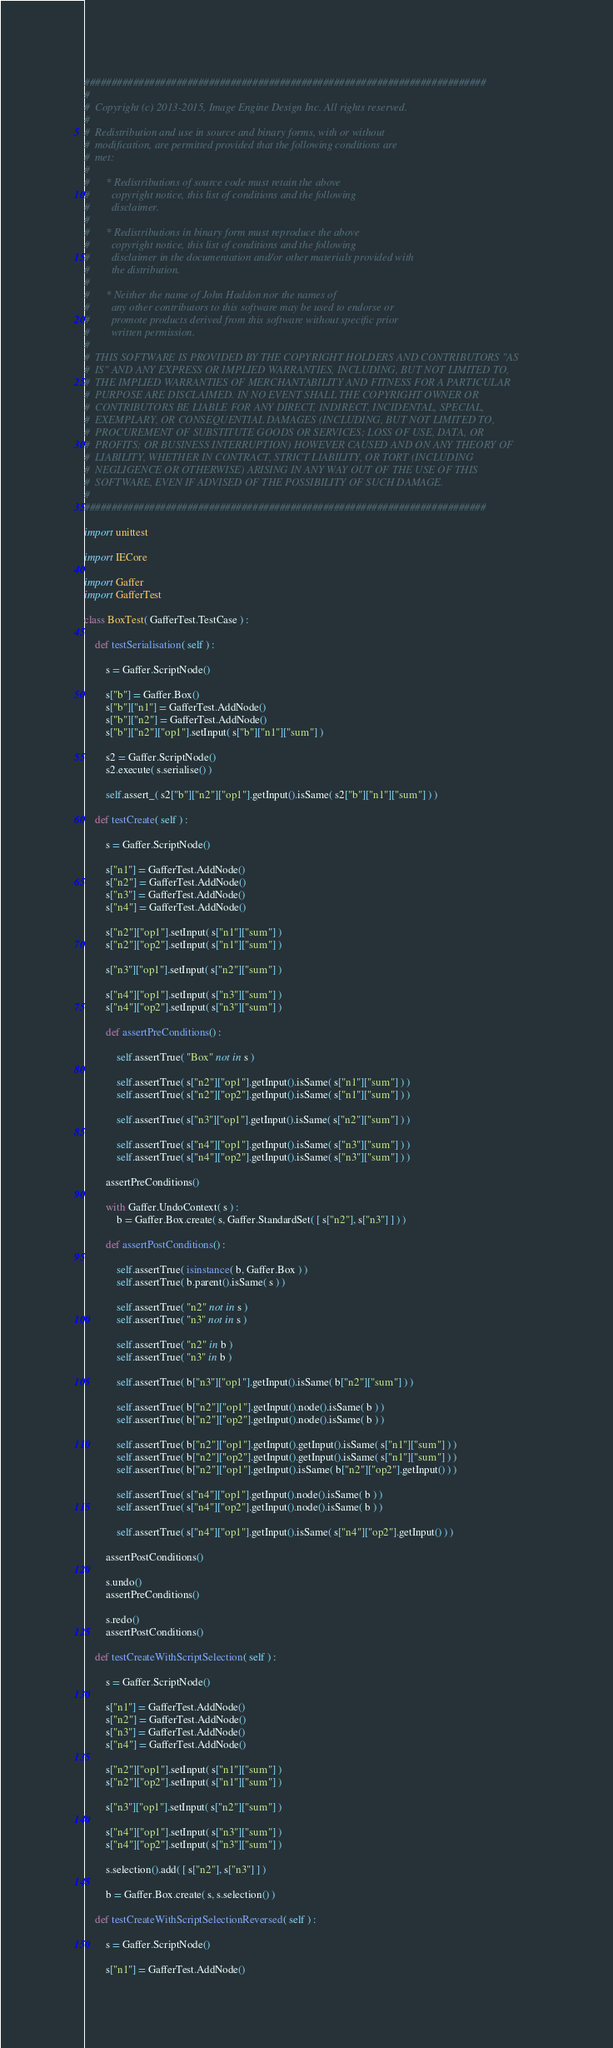<code> <loc_0><loc_0><loc_500><loc_500><_Python_>##########################################################################
#
#  Copyright (c) 2013-2015, Image Engine Design Inc. All rights reserved.
#
#  Redistribution and use in source and binary forms, with or without
#  modification, are permitted provided that the following conditions are
#  met:
#
#      * Redistributions of source code must retain the above
#        copyright notice, this list of conditions and the following
#        disclaimer.
#
#      * Redistributions in binary form must reproduce the above
#        copyright notice, this list of conditions and the following
#        disclaimer in the documentation and/or other materials provided with
#        the distribution.
#
#      * Neither the name of John Haddon nor the names of
#        any other contributors to this software may be used to endorse or
#        promote products derived from this software without specific prior
#        written permission.
#
#  THIS SOFTWARE IS PROVIDED BY THE COPYRIGHT HOLDERS AND CONTRIBUTORS "AS
#  IS" AND ANY EXPRESS OR IMPLIED WARRANTIES, INCLUDING, BUT NOT LIMITED TO,
#  THE IMPLIED WARRANTIES OF MERCHANTABILITY AND FITNESS FOR A PARTICULAR
#  PURPOSE ARE DISCLAIMED. IN NO EVENT SHALL THE COPYRIGHT OWNER OR
#  CONTRIBUTORS BE LIABLE FOR ANY DIRECT, INDIRECT, INCIDENTAL, SPECIAL,
#  EXEMPLARY, OR CONSEQUENTIAL DAMAGES (INCLUDING, BUT NOT LIMITED TO,
#  PROCUREMENT OF SUBSTITUTE GOODS OR SERVICES; LOSS OF USE, DATA, OR
#  PROFITS; OR BUSINESS INTERRUPTION) HOWEVER CAUSED AND ON ANY THEORY OF
#  LIABILITY, WHETHER IN CONTRACT, STRICT LIABILITY, OR TORT (INCLUDING
#  NEGLIGENCE OR OTHERWISE) ARISING IN ANY WAY OUT OF THE USE OF THIS
#  SOFTWARE, EVEN IF ADVISED OF THE POSSIBILITY OF SUCH DAMAGE.
#
##########################################################################

import unittest

import IECore

import Gaffer
import GafferTest

class BoxTest( GafferTest.TestCase ) :

	def testSerialisation( self ) :

		s = Gaffer.ScriptNode()

		s["b"] = Gaffer.Box()
		s["b"]["n1"] = GafferTest.AddNode()
		s["b"]["n2"] = GafferTest.AddNode()
		s["b"]["n2"]["op1"].setInput( s["b"]["n1"]["sum"] )

		s2 = Gaffer.ScriptNode()
		s2.execute( s.serialise() )

		self.assert_( s2["b"]["n2"]["op1"].getInput().isSame( s2["b"]["n1"]["sum"] ) )

	def testCreate( self ) :

		s = Gaffer.ScriptNode()

		s["n1"] = GafferTest.AddNode()
		s["n2"] = GafferTest.AddNode()
		s["n3"] = GafferTest.AddNode()
		s["n4"] = GafferTest.AddNode()

		s["n2"]["op1"].setInput( s["n1"]["sum"] )
		s["n2"]["op2"].setInput( s["n1"]["sum"] )

		s["n3"]["op1"].setInput( s["n2"]["sum"] )

		s["n4"]["op1"].setInput( s["n3"]["sum"] )
		s["n4"]["op2"].setInput( s["n3"]["sum"] )

		def assertPreConditions() :

			self.assertTrue( "Box" not in s )

			self.assertTrue( s["n2"]["op1"].getInput().isSame( s["n1"]["sum"] ) )
			self.assertTrue( s["n2"]["op2"].getInput().isSame( s["n1"]["sum"] ) )

			self.assertTrue( s["n3"]["op1"].getInput().isSame( s["n2"]["sum"] ) )

			self.assertTrue( s["n4"]["op1"].getInput().isSame( s["n3"]["sum"] ) )
			self.assertTrue( s["n4"]["op2"].getInput().isSame( s["n3"]["sum"] ) )

		assertPreConditions()

		with Gaffer.UndoContext( s ) :
			b = Gaffer.Box.create( s, Gaffer.StandardSet( [ s["n2"], s["n3"] ] ) )

		def assertPostConditions() :

			self.assertTrue( isinstance( b, Gaffer.Box ) )
			self.assertTrue( b.parent().isSame( s ) )

			self.assertTrue( "n2" not in s )
			self.assertTrue( "n3" not in s )

			self.assertTrue( "n2" in b )
			self.assertTrue( "n3" in b )

			self.assertTrue( b["n3"]["op1"].getInput().isSame( b["n2"]["sum"] ) )

			self.assertTrue( b["n2"]["op1"].getInput().node().isSame( b ) )
			self.assertTrue( b["n2"]["op2"].getInput().node().isSame( b ) )

			self.assertTrue( b["n2"]["op1"].getInput().getInput().isSame( s["n1"]["sum"] ) )
			self.assertTrue( b["n2"]["op2"].getInput().getInput().isSame( s["n1"]["sum"] ) )
			self.assertTrue( b["n2"]["op1"].getInput().isSame( b["n2"]["op2"].getInput() ) )

			self.assertTrue( s["n4"]["op1"].getInput().node().isSame( b ) )
			self.assertTrue( s["n4"]["op2"].getInput().node().isSame( b ) )

			self.assertTrue( s["n4"]["op1"].getInput().isSame( s["n4"]["op2"].getInput() ) )

		assertPostConditions()

		s.undo()
		assertPreConditions()

		s.redo()
		assertPostConditions()

	def testCreateWithScriptSelection( self ) :

		s = Gaffer.ScriptNode()

		s["n1"] = GafferTest.AddNode()
		s["n2"] = GafferTest.AddNode()
		s["n3"] = GafferTest.AddNode()
		s["n4"] = GafferTest.AddNode()

		s["n2"]["op1"].setInput( s["n1"]["sum"] )
		s["n2"]["op2"].setInput( s["n1"]["sum"] )

		s["n3"]["op1"].setInput( s["n2"]["sum"] )

		s["n4"]["op1"].setInput( s["n3"]["sum"] )
		s["n4"]["op2"].setInput( s["n3"]["sum"] )

		s.selection().add( [ s["n2"], s["n3"] ] )

		b = Gaffer.Box.create( s, s.selection() )

	def testCreateWithScriptSelectionReversed( self ) :

		s = Gaffer.ScriptNode()

		s["n1"] = GafferTest.AddNode()</code> 